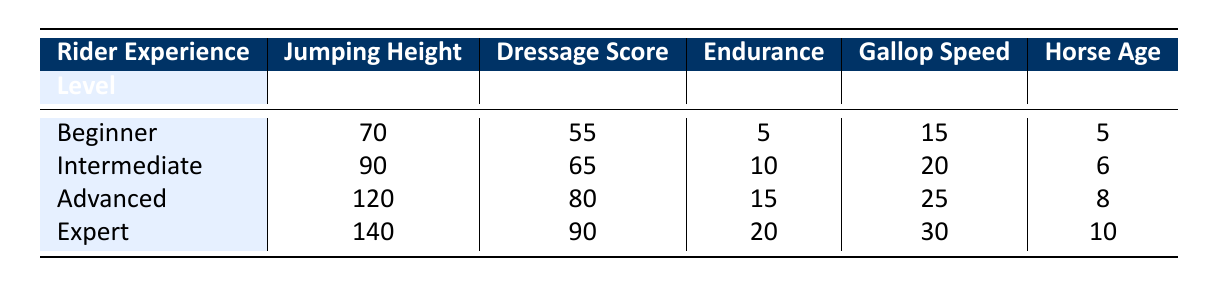What is the jumping height for the Advanced rider experience level? The table shows the jumping height for the Advanced rider experience level is listed under the "Jumping Height" column for that specific level, which states 120 cm.
Answer: 120 cm How much endurance distance can an Intermediate rider horse cover? According to the table, the endurance distance for the Intermediate rider experience level is directly noted in the respective column, which is 10 km.
Answer: 10 km Is the dressage score higher for an Expert rider compared to an Advanced rider? The table shows that the dressage score for Expert riders is 90, while for Advanced riders, it is 80. Since 90 is greater than 80, this indicates that the Expert's score is indeed higher.
Answer: Yes What is the gallop speed difference between Beginner and Expert riders? The gallop speed for Beginner riders is 15 km/h, and for Expert riders, it is 30 km/h. We subtract the Beginner's speed from the Expert's: 30 - 15 = 15 km/h.
Answer: 15 km/h What is the average horse age across all rider experience levels in the table? The horse ages for each level are 5, 6, 8, and 10 years. To find the average, we sum up these values: 5 + 6 + 8 + 10 = 29 years. Then divide by the number of levels (4): 29 / 4 = 7.25 years.
Answer: 7.25 years How does the endurance distance of the Expert correlate with the horse's age? The table shows that the endurance distance for Expert riders is 20 km, and the horse age is 10 years. Since both are at the highest values compared to other levels, it suggests that more experienced riding is associated with older horse age and increased endurance.
Answer: Strong correlation Is it true that an Intermediate rider has a higher dressage score than a Beginner? The table indicates the dressage score for Intermediate riders is 65 and for Beginner riders, it is 55. Since 65 is greater than 55, the statement is true.
Answer: Yes What is the total jumping height for all rider experience levels combined? The jumping heights are 70 cm, 90 cm, 120 cm, and 140 cm. Adding these: 70 + 90 + 120 + 140 = 420 cm. Thus, the total jumping height is 420 cm.
Answer: 420 cm 